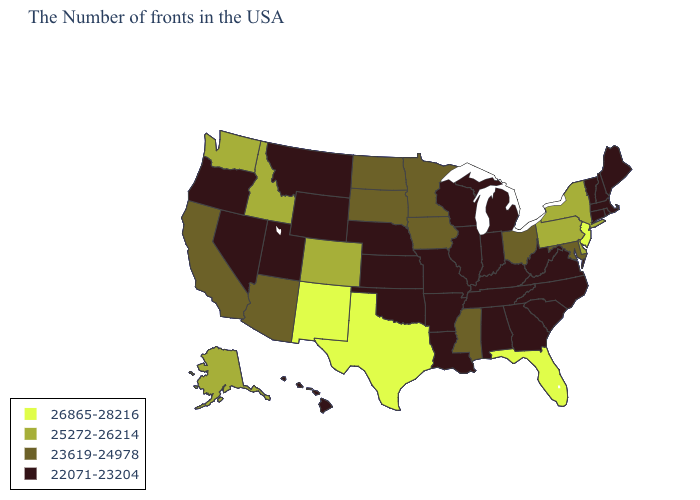What is the value of Alaska?
Concise answer only. 25272-26214. Which states hav the highest value in the Northeast?
Quick response, please. New Jersey. What is the value of Florida?
Short answer required. 26865-28216. Name the states that have a value in the range 25272-26214?
Keep it brief. New York, Delaware, Pennsylvania, Colorado, Idaho, Washington, Alaska. Among the states that border Utah , which have the highest value?
Keep it brief. New Mexico. How many symbols are there in the legend?
Short answer required. 4. Among the states that border West Virginia , which have the highest value?
Answer briefly. Pennsylvania. Does the map have missing data?
Write a very short answer. No. Does Florida have the same value as New Jersey?
Be succinct. Yes. Among the states that border Arkansas , does Texas have the highest value?
Concise answer only. Yes. How many symbols are there in the legend?
Concise answer only. 4. Name the states that have a value in the range 22071-23204?
Concise answer only. Maine, Massachusetts, Rhode Island, New Hampshire, Vermont, Connecticut, Virginia, North Carolina, South Carolina, West Virginia, Georgia, Michigan, Kentucky, Indiana, Alabama, Tennessee, Wisconsin, Illinois, Louisiana, Missouri, Arkansas, Kansas, Nebraska, Oklahoma, Wyoming, Utah, Montana, Nevada, Oregon, Hawaii. Does Maine have the highest value in the USA?
Write a very short answer. No. Does Iowa have the highest value in the MidWest?
Give a very brief answer. Yes. Name the states that have a value in the range 25272-26214?
Concise answer only. New York, Delaware, Pennsylvania, Colorado, Idaho, Washington, Alaska. 